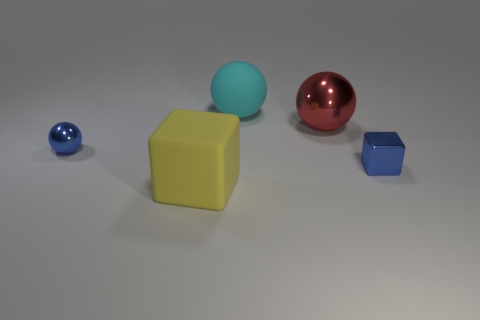What shape is the small shiny thing that is the same color as the small ball?
Your response must be concise. Cube. Do the block to the right of the red shiny thing and the ball to the left of the cyan object have the same material?
Your answer should be compact. Yes. The tiny thing on the right side of the big object that is in front of the big metallic object is made of what material?
Your answer should be compact. Metal. How big is the metallic sphere that is right of the large matte thing behind the tiny blue metal object on the left side of the large cube?
Keep it short and to the point. Large. Does the rubber cube have the same size as the blue block?
Make the answer very short. No. There is a small blue shiny thing that is on the right side of the cyan rubber object; does it have the same shape as the small metallic thing that is to the left of the big cyan rubber sphere?
Provide a short and direct response. No. There is a tiny blue object behind the small blue metallic block; are there any things that are right of it?
Provide a short and direct response. Yes. Is there a yellow shiny cylinder?
Make the answer very short. No. What number of blue blocks are the same size as the yellow rubber thing?
Your answer should be very brief. 0. How many things are both in front of the large red metal sphere and right of the cyan matte object?
Keep it short and to the point. 1. 